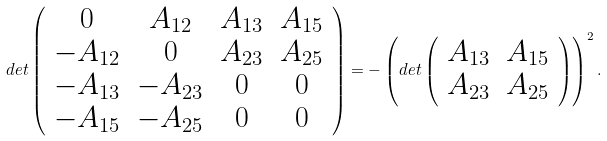<formula> <loc_0><loc_0><loc_500><loc_500>d e t \left ( \begin{array} { c c c c } { 0 } & { { A _ { 1 2 } } } & { { A _ { 1 3 } } } & { { A _ { 1 5 } } } \\ { { - A _ { 1 2 } } } & { 0 } & { { A _ { 2 3 } } } & { { A _ { 2 5 } } } \\ { { - A _ { 1 3 } } } & { { - A _ { 2 3 } } } & { 0 } & { 0 } \\ { { - A _ { 1 5 } } } & { { - A _ { 2 5 } } } & { 0 } & { 0 } \end{array} \right ) = - \left ( d e t \left ( \begin{array} { c c } { { A _ { 1 3 } } } & { { A _ { 1 5 } } } \\ { { A _ { 2 3 } } } & { { A _ { 2 5 } } } \end{array} \right ) \right ) ^ { 2 } .</formula> 